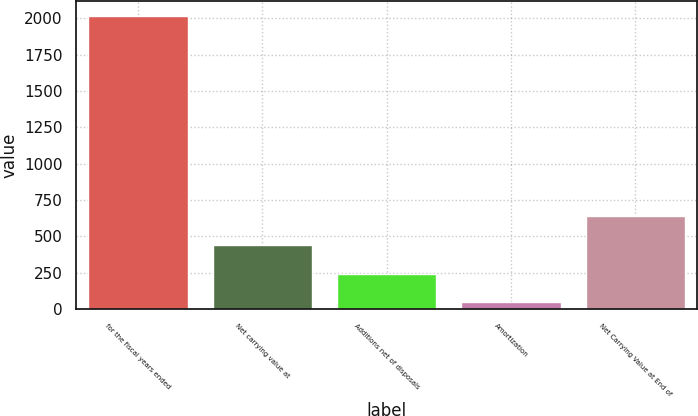Convert chart to OTSL. <chart><loc_0><loc_0><loc_500><loc_500><bar_chart><fcel>for the fiscal years ended<fcel>Net carrying value at<fcel>Additions net of disposals<fcel>Amortization<fcel>Net Carrying Value at End of<nl><fcel>2018<fcel>441.28<fcel>244.19<fcel>47.1<fcel>638.37<nl></chart> 